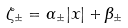<formula> <loc_0><loc_0><loc_500><loc_500>\zeta _ { \pm } = \alpha _ { \pm } | x | + \beta _ { \pm }</formula> 